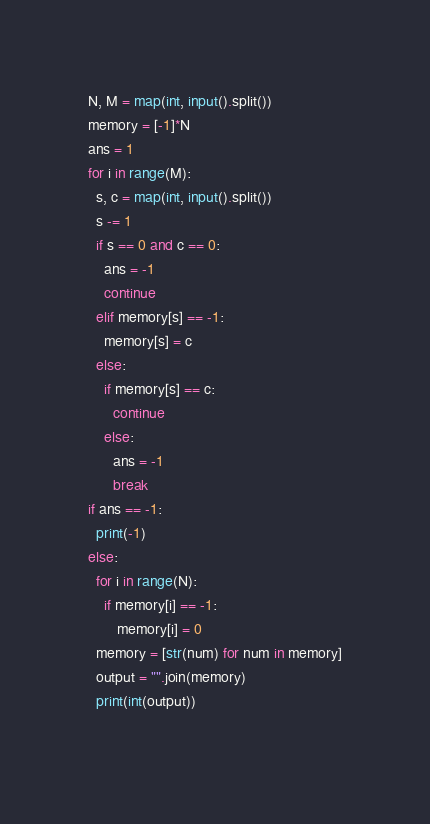Convert code to text. <code><loc_0><loc_0><loc_500><loc_500><_Python_>N, M = map(int, input().split())
memory = [-1]*N
ans = 1
for i in range(M):
  s, c = map(int, input().split())
  s -= 1
  if s == 0 and c == 0:
    ans = -1
    continue
  elif memory[s] == -1:
    memory[s] = c
  else:
    if memory[s] == c:
      continue
    else:
      ans = -1
      break
if ans == -1:
  print(-1)
else:
  for i in range(N):
    if memory[i] == -1:
       memory[i] = 0
  memory = [str(num) for num in memory]
  output = "".join(memory)
  print(int(output))
    </code> 